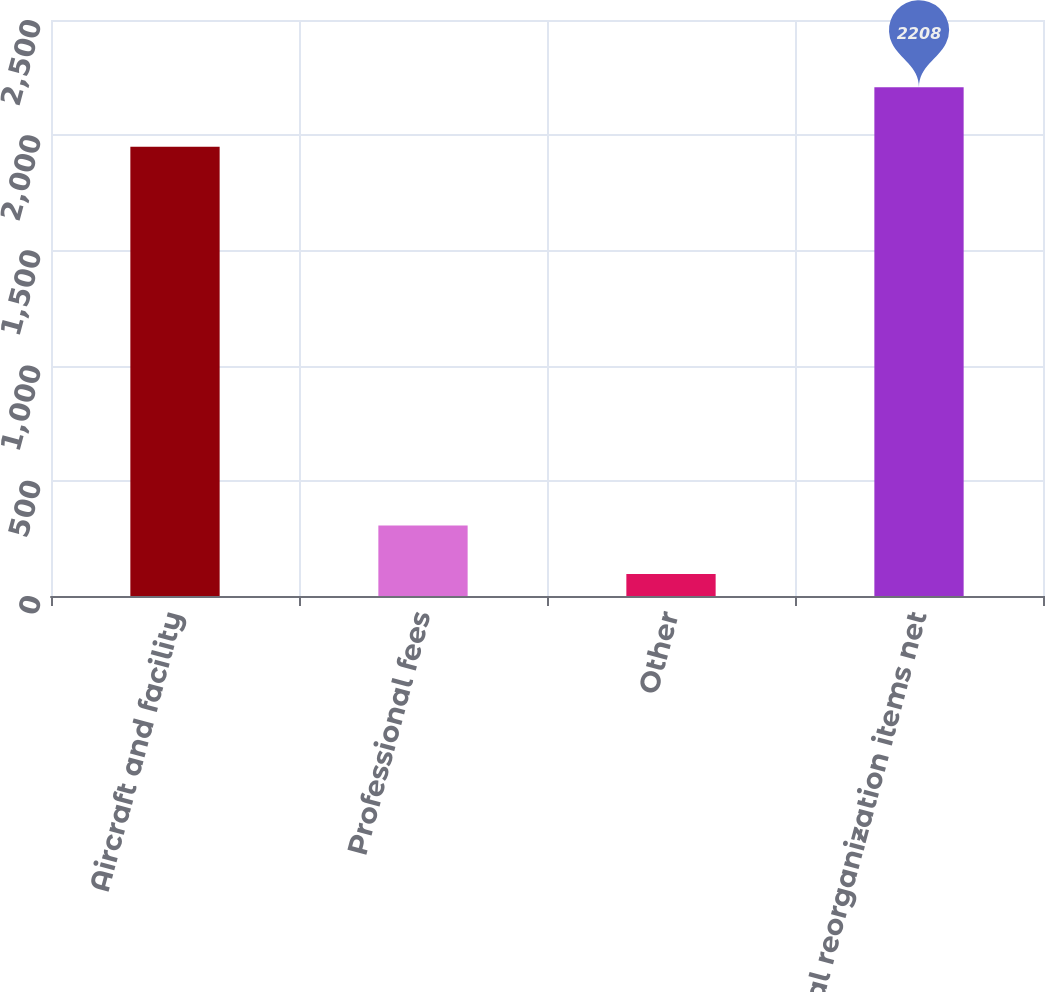Convert chart. <chart><loc_0><loc_0><loc_500><loc_500><bar_chart><fcel>Aircraft and facility<fcel>Professional fees<fcel>Other<fcel>Total reorganization items net<nl><fcel>1950<fcel>306.3<fcel>95<fcel>2208<nl></chart> 